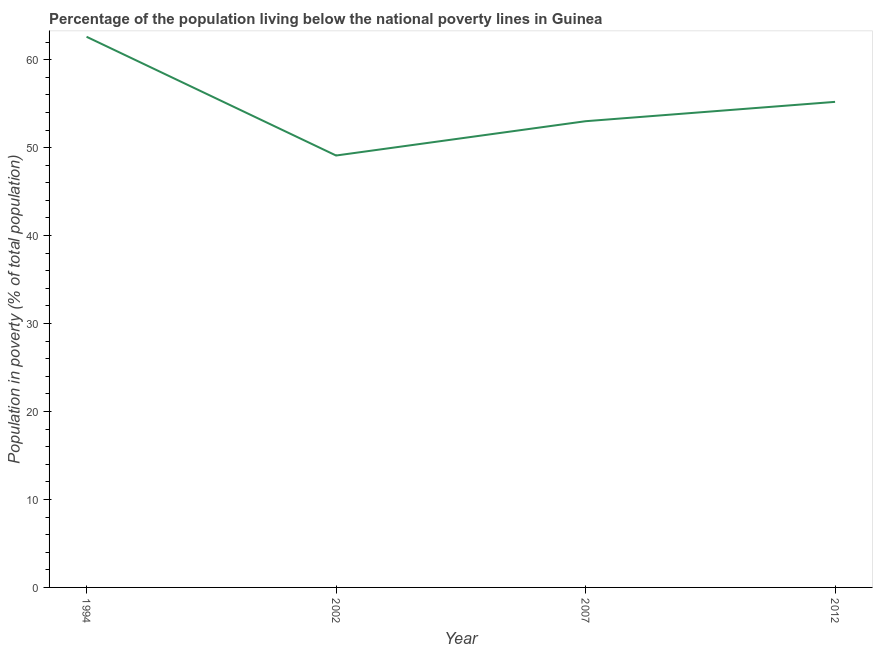What is the percentage of population living below poverty line in 1994?
Your response must be concise. 62.6. Across all years, what is the maximum percentage of population living below poverty line?
Your answer should be very brief. 62.6. Across all years, what is the minimum percentage of population living below poverty line?
Offer a very short reply. 49.1. In which year was the percentage of population living below poverty line maximum?
Keep it short and to the point. 1994. What is the sum of the percentage of population living below poverty line?
Ensure brevity in your answer.  219.9. What is the difference between the percentage of population living below poverty line in 2002 and 2007?
Provide a succinct answer. -3.9. What is the average percentage of population living below poverty line per year?
Give a very brief answer. 54.97. What is the median percentage of population living below poverty line?
Keep it short and to the point. 54.1. In how many years, is the percentage of population living below poverty line greater than 54 %?
Offer a very short reply. 2. What is the ratio of the percentage of population living below poverty line in 2002 to that in 2007?
Your response must be concise. 0.93. Is the percentage of population living below poverty line in 2007 less than that in 2012?
Give a very brief answer. Yes. What is the difference between the highest and the second highest percentage of population living below poverty line?
Your response must be concise. 7.4. What is the difference between the highest and the lowest percentage of population living below poverty line?
Make the answer very short. 13.5. Does the percentage of population living below poverty line monotonically increase over the years?
Your answer should be compact. No. How many lines are there?
Give a very brief answer. 1. How many years are there in the graph?
Ensure brevity in your answer.  4. What is the difference between two consecutive major ticks on the Y-axis?
Make the answer very short. 10. Are the values on the major ticks of Y-axis written in scientific E-notation?
Keep it short and to the point. No. Does the graph contain any zero values?
Your answer should be compact. No. Does the graph contain grids?
Keep it short and to the point. No. What is the title of the graph?
Offer a terse response. Percentage of the population living below the national poverty lines in Guinea. What is the label or title of the Y-axis?
Offer a very short reply. Population in poverty (% of total population). What is the Population in poverty (% of total population) of 1994?
Your response must be concise. 62.6. What is the Population in poverty (% of total population) in 2002?
Ensure brevity in your answer.  49.1. What is the Population in poverty (% of total population) of 2012?
Provide a short and direct response. 55.2. What is the difference between the Population in poverty (% of total population) in 1994 and 2002?
Offer a terse response. 13.5. What is the difference between the Population in poverty (% of total population) in 1994 and 2007?
Make the answer very short. 9.6. What is the ratio of the Population in poverty (% of total population) in 1994 to that in 2002?
Provide a short and direct response. 1.27. What is the ratio of the Population in poverty (% of total population) in 1994 to that in 2007?
Make the answer very short. 1.18. What is the ratio of the Population in poverty (% of total population) in 1994 to that in 2012?
Your answer should be very brief. 1.13. What is the ratio of the Population in poverty (% of total population) in 2002 to that in 2007?
Ensure brevity in your answer.  0.93. What is the ratio of the Population in poverty (% of total population) in 2002 to that in 2012?
Keep it short and to the point. 0.89. What is the ratio of the Population in poverty (% of total population) in 2007 to that in 2012?
Ensure brevity in your answer.  0.96. 